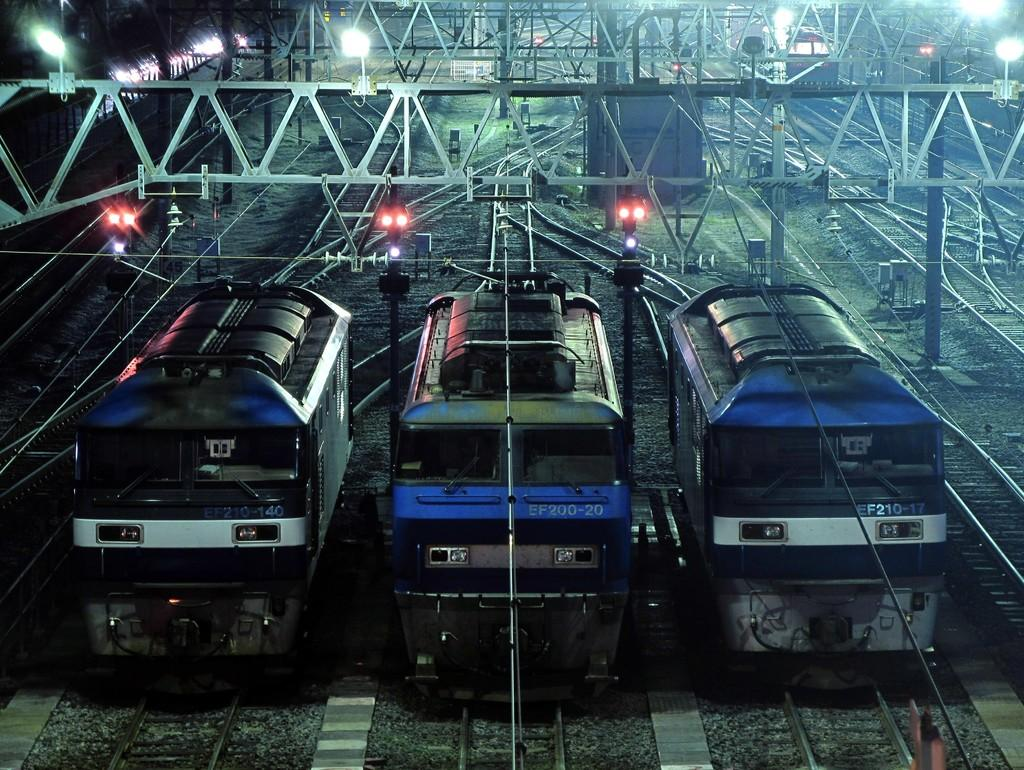What type of vehicles are in the image? There are train engines in the image. What is the infrastructure for the train engines to travel on? There are railway tracks in the image. What are the rods used for in the image? The purpose of the rods is not specified in the facts, but they are visible in the image. Where is the train located in the image? The train is on the left side of the image. What structures provide illumination in the image? There are light poles in the image. What type of reward is being given to the pets in the image? There are no pets or rewards present in the image. What color is the paint on the train in the image? There is no information about the color of the train or any paint in the image. 